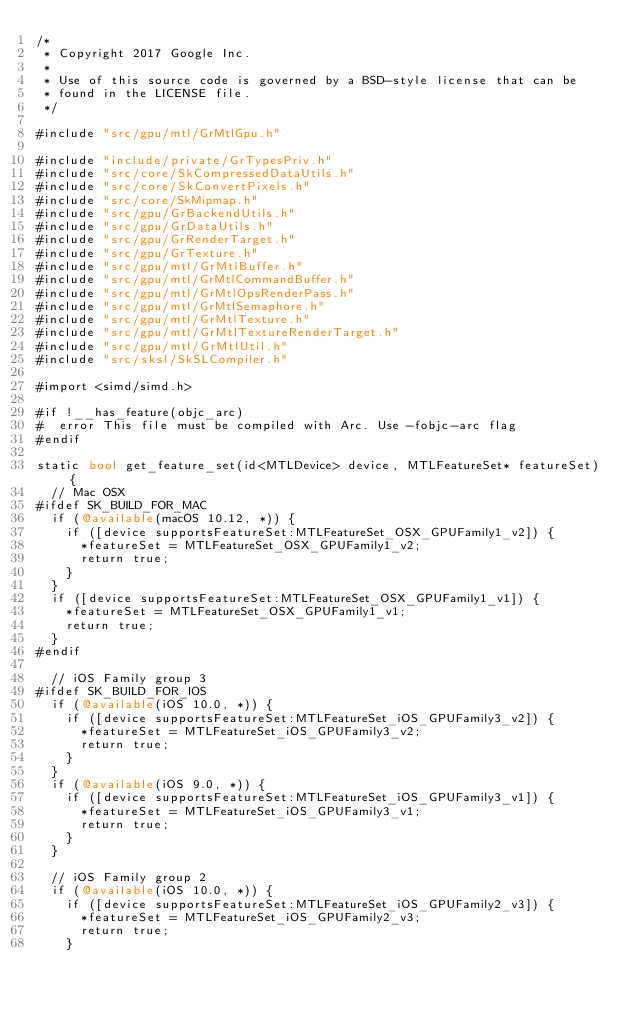<code> <loc_0><loc_0><loc_500><loc_500><_ObjectiveC_>/*
 * Copyright 2017 Google Inc.
 *
 * Use of this source code is governed by a BSD-style license that can be
 * found in the LICENSE file.
 */

#include "src/gpu/mtl/GrMtlGpu.h"

#include "include/private/GrTypesPriv.h"
#include "src/core/SkCompressedDataUtils.h"
#include "src/core/SkConvertPixels.h"
#include "src/core/SkMipmap.h"
#include "src/gpu/GrBackendUtils.h"
#include "src/gpu/GrDataUtils.h"
#include "src/gpu/GrRenderTarget.h"
#include "src/gpu/GrTexture.h"
#include "src/gpu/mtl/GrMtlBuffer.h"
#include "src/gpu/mtl/GrMtlCommandBuffer.h"
#include "src/gpu/mtl/GrMtlOpsRenderPass.h"
#include "src/gpu/mtl/GrMtlSemaphore.h"
#include "src/gpu/mtl/GrMtlTexture.h"
#include "src/gpu/mtl/GrMtlTextureRenderTarget.h"
#include "src/gpu/mtl/GrMtlUtil.h"
#include "src/sksl/SkSLCompiler.h"

#import <simd/simd.h>

#if !__has_feature(objc_arc)
#  error This file must be compiled with Arc. Use -fobjc-arc flag
#endif

static bool get_feature_set(id<MTLDevice> device, MTLFeatureSet* featureSet) {
  // Mac OSX
#ifdef SK_BUILD_FOR_MAC
  if (@available(macOS 10.12, *)) {
    if ([device supportsFeatureSet:MTLFeatureSet_OSX_GPUFamily1_v2]) {
      *featureSet = MTLFeatureSet_OSX_GPUFamily1_v2;
      return true;
    }
  }
  if ([device supportsFeatureSet:MTLFeatureSet_OSX_GPUFamily1_v1]) {
    *featureSet = MTLFeatureSet_OSX_GPUFamily1_v1;
    return true;
  }
#endif

  // iOS Family group 3
#ifdef SK_BUILD_FOR_IOS
  if (@available(iOS 10.0, *)) {
    if ([device supportsFeatureSet:MTLFeatureSet_iOS_GPUFamily3_v2]) {
      *featureSet = MTLFeatureSet_iOS_GPUFamily3_v2;
      return true;
    }
  }
  if (@available(iOS 9.0, *)) {
    if ([device supportsFeatureSet:MTLFeatureSet_iOS_GPUFamily3_v1]) {
      *featureSet = MTLFeatureSet_iOS_GPUFamily3_v1;
      return true;
    }
  }

  // iOS Family group 2
  if (@available(iOS 10.0, *)) {
    if ([device supportsFeatureSet:MTLFeatureSet_iOS_GPUFamily2_v3]) {
      *featureSet = MTLFeatureSet_iOS_GPUFamily2_v3;
      return true;
    }</code> 